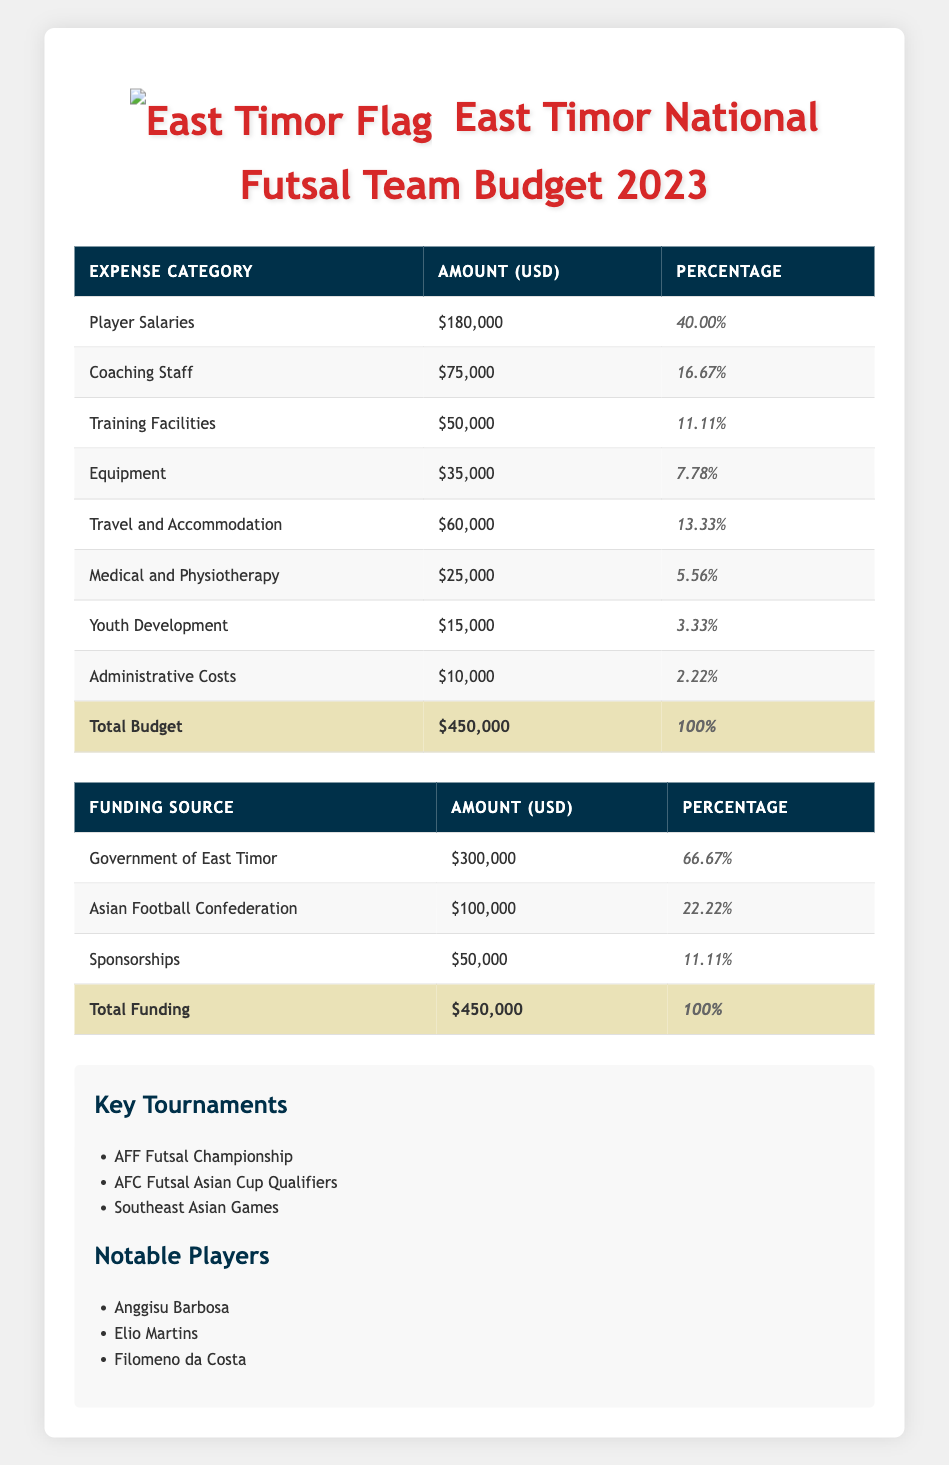What is the total budget for East Timor's national futsal team in 2023? The total budget is explicitly listed in the table under 'Total Budget.' It states that the total budget is $450,000.
Answer: 450000 How much is allocated for player salaries? The amount for player salaries is found in the expense categories in the table. It specifies that the amount allocated for player salaries is $180,000.
Answer: 180000 What percentage of the total budget is dedicated to travel and accommodation? The percentage for travel and accommodation is given in the expense categories. It states that travel and accommodation receives 13.33% of the total budget.
Answer: 13.33 Is the funding from sponsorships higher than funding from youth development? We compare the amounts listed for sponsorships ($50,000) and youth development ($15,000). Since $50,000 is greater than $15,000, the statement is true.
Answer: Yes How much more is spent on coaching staff compared to medical and physiotherapy? To find the difference, we take the amount for coaching staff ($75,000) and subtract the amount for medical and physiotherapy ($25,000). This equals $75,000 - $25,000 = $50,000.
Answer: 50000 What is the total amount allocated for both training facilities and equipment? We add the respective amounts together: training facilities ($50,000) + equipment ($35,000) = $85,000.
Answer: 85000 Which funding source contributes the most to the budget? We compare the amounts of each funding source: Government of East Timor ($300,000), Asian Football Confederation ($100,000), and Sponsorships ($50,000). The Government of East Timor has the highest contribution.
Answer: Government of East Timor What fraction of the total budget is utilized for youth development? The amount for youth development is $15,000. The total budget is $450,000. The fraction is calculated by dividing the two values: 15,000 / 450,000, which simplifies to 1/30.
Answer: 1/30 Are the total expenses for equipment and medical and physiotherapy equal to the funds from sponsorships? The total expenses for equipment ($35,000) and medical and physiotherapy ($25,000) are summed up to $60,000. The funds from sponsorships are $50,000. Since $60,000 is not equal to $50,000, the statement is false.
Answer: No 